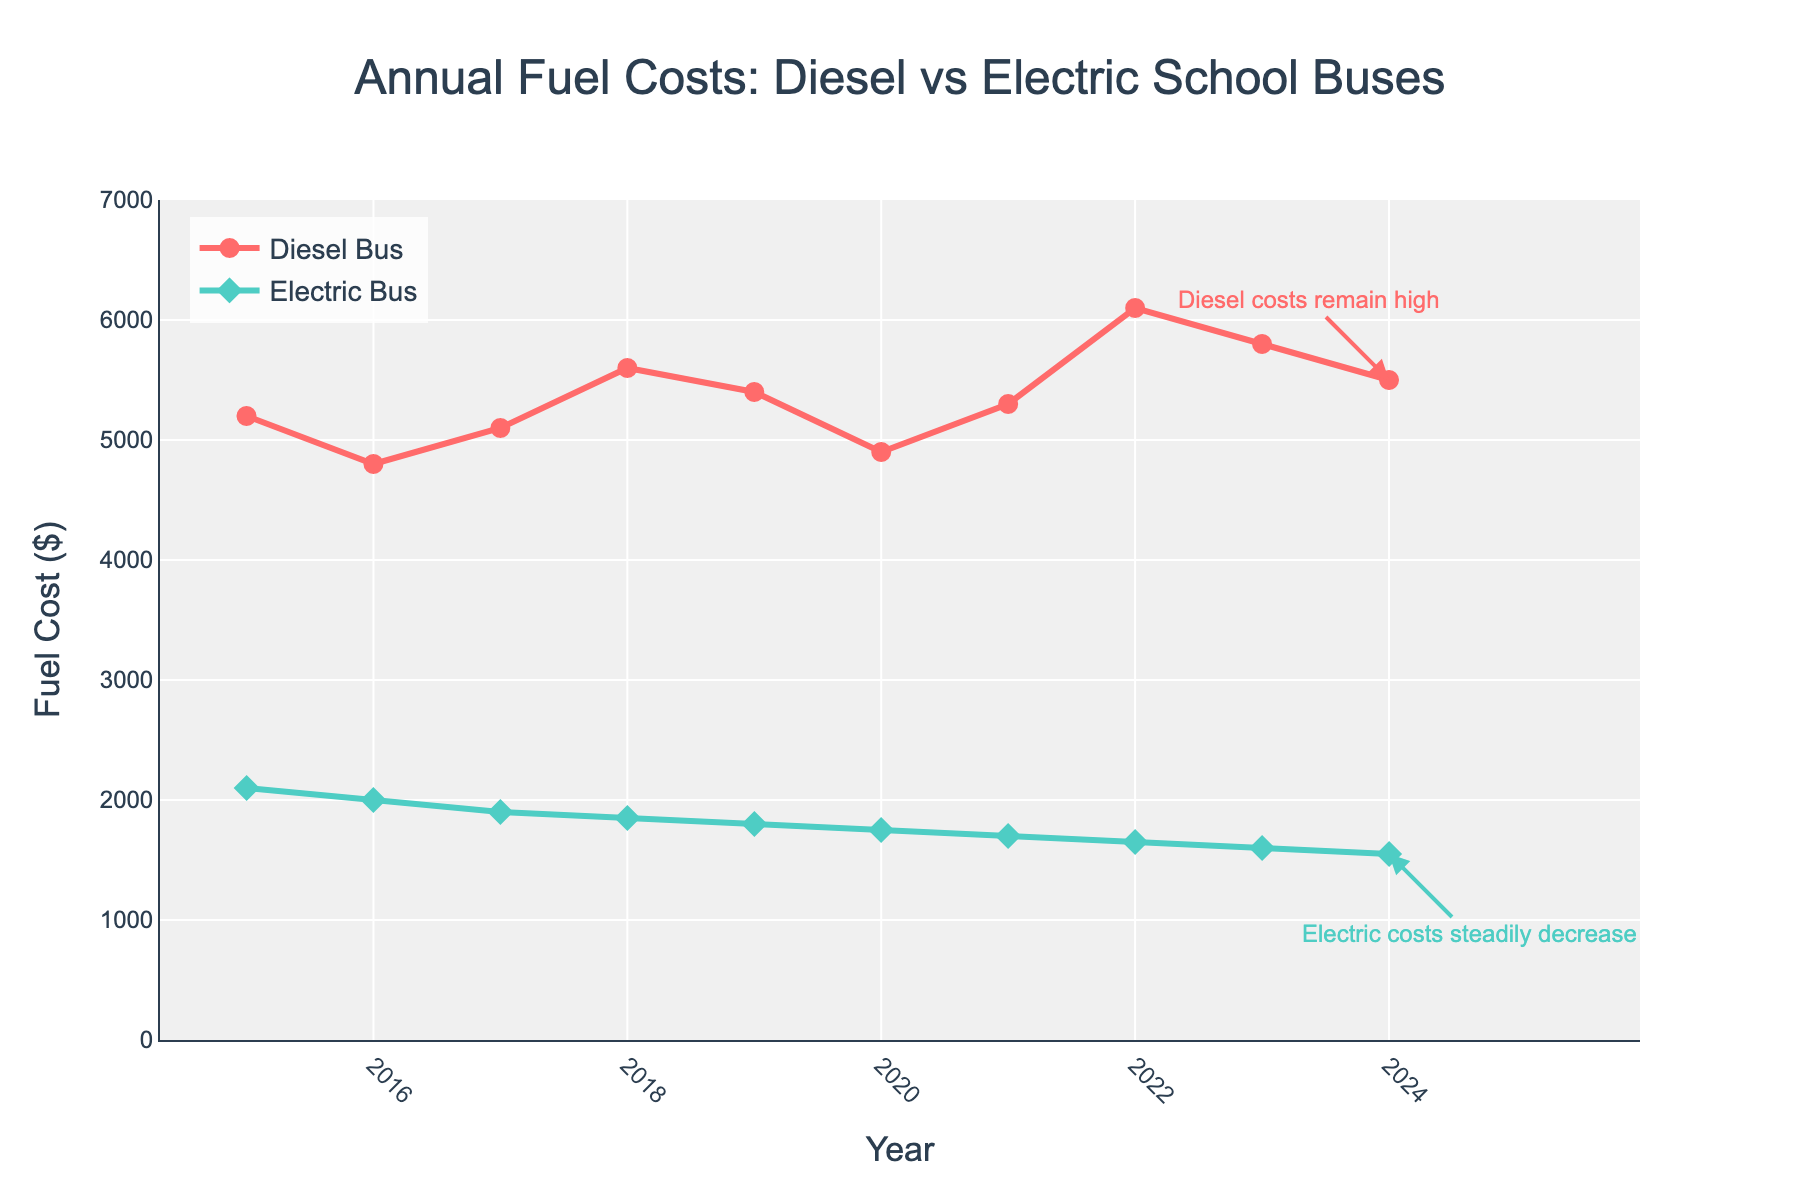Which year had the highest fuel cost for diesel buses? By examining the line chart for the Diesel Bus Fuel Cost, we see that the highest point is in the year 2022, reaching $6100.
Answer: 2022 What was the difference in fuel costs between diesel and electric buses in 2024? To find the difference, look at the data for diesel and electric buses in 2024. The diesel bus cost is $5500 and the electric bus cost is $1550. Calculating the difference: $5500 - $1550 = $3950.
Answer: $3950 How did the fuel cost for electric buses change from 2015 to 2024? Comparing the fuel costs for electric buses in 2015 ($2100) and in 2024 ($1550), the cost decreased. The change can be quantified as $2100 - $1550 = $550.
Answer: Decreased by $550 Which year saw the greatest decrease in diesel bus fuel costs from the previous year? By examining the yearly changes, the greatest decrease is seen between 2017 and 2018, where the cost dropped from $5100 to $4800, a difference of $300.
Answer: 2017-2018 Are fuel costs for electric buses generally increasing or decreasing over the years? Observing the trend in the line chart for electric buses from 2015 to 2024, the costs show a steady decrease year over year.
Answer: Decreasing In which year do diesel and electric bus fuel costs have the smallest difference? By comparing the differences year by year, the smallest difference is in 2015: Diesel ($5200) and Electric ($2100), giving a difference of $3100. No other year has a smaller gap than $3100.
Answer: 2015 How much did the diesel bus fuel cost change from 2015 to 2024? Looking at the chart: the diesel bus fuel cost in 2015 was $5200 and in 2024 it was $5500. So the change is $5500 - $5200 = $300.
Answer: Increased by $300 Which type of bus experienced a more consistent decline in fuel cost? Comparing the slopes of the lines for both types of buses, the line for electric bus costs shows a consistently downward trend, while the diesel bus costs fluctuate.
Answer: Electric Bus 